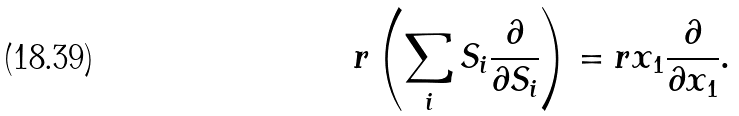Convert formula to latex. <formula><loc_0><loc_0><loc_500><loc_500>r \left ( \sum _ { i } S _ { i } \frac { \partial } { \partial S _ { i } } \right ) = r x _ { 1 } \frac { \partial } { \partial x _ { 1 } } .</formula> 